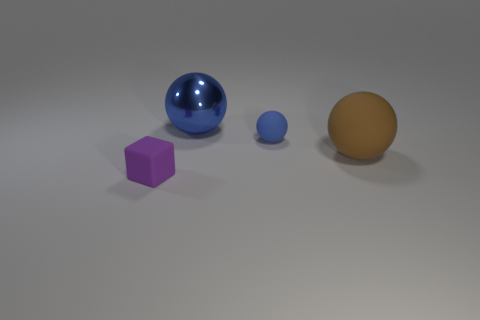Assuming these objects are planets, can you create a story describing this mini solar system? In this miniature galactic tableau, the purple cube planet, known as Cubion, boasts a terrain of perfectly flat surfaces and sharp edges, a world where geometry and precision rule. The large blue sphere, Aquarine, gleams with oceans covering its entirety and mirrors the cosmos on its shiny surface, a beacon for celestial navigation. Its smaller companion, Azurette, is a tranquil orb where the pace of life is slow and serene. Lastly, the brown sphere, Terraferma, is a haven for land dwellers, with sprawling continents and diverse ecosystems. Together, they orbit in harmony in a unique and fantastical solar system. 